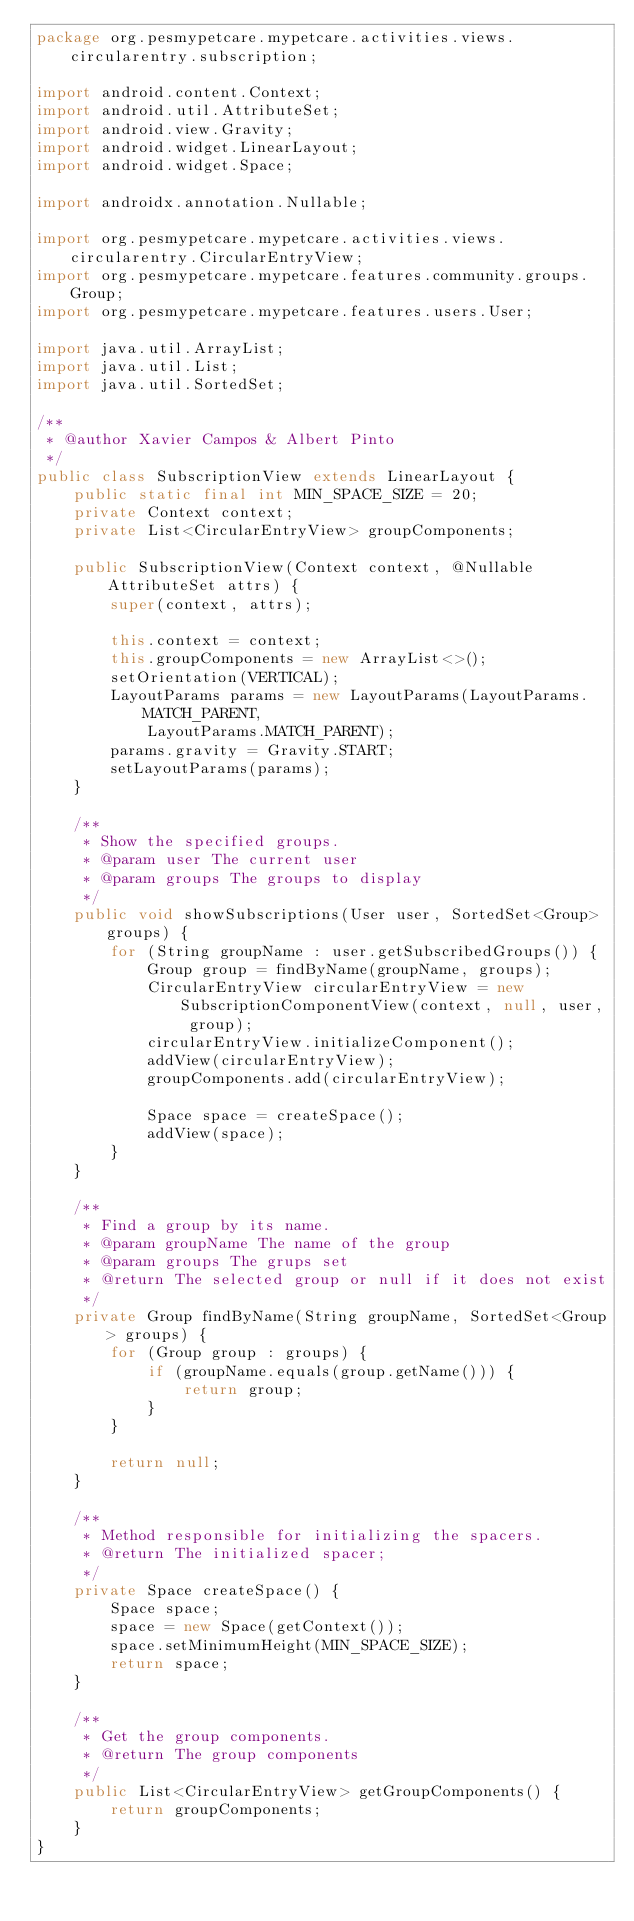Convert code to text. <code><loc_0><loc_0><loc_500><loc_500><_Java_>package org.pesmypetcare.mypetcare.activities.views.circularentry.subscription;

import android.content.Context;
import android.util.AttributeSet;
import android.view.Gravity;
import android.widget.LinearLayout;
import android.widget.Space;

import androidx.annotation.Nullable;

import org.pesmypetcare.mypetcare.activities.views.circularentry.CircularEntryView;
import org.pesmypetcare.mypetcare.features.community.groups.Group;
import org.pesmypetcare.mypetcare.features.users.User;

import java.util.ArrayList;
import java.util.List;
import java.util.SortedSet;

/**
 * @author Xavier Campos & Albert Pinto
 */
public class SubscriptionView extends LinearLayout {
    public static final int MIN_SPACE_SIZE = 20;
    private Context context;
    private List<CircularEntryView> groupComponents;

    public SubscriptionView(Context context, @Nullable AttributeSet attrs) {
        super(context, attrs);

        this.context = context;
        this.groupComponents = new ArrayList<>();
        setOrientation(VERTICAL);
        LayoutParams params = new LayoutParams(LayoutParams.MATCH_PARENT,
            LayoutParams.MATCH_PARENT);
        params.gravity = Gravity.START;
        setLayoutParams(params);
    }

    /**
     * Show the specified groups.
     * @param user The current user
     * @param groups The groups to display
     */
    public void showSubscriptions(User user, SortedSet<Group> groups) {
        for (String groupName : user.getSubscribedGroups()) {
            Group group = findByName(groupName, groups);
            CircularEntryView circularEntryView = new SubscriptionComponentView(context, null, user, group);
            circularEntryView.initializeComponent();
            addView(circularEntryView);
            groupComponents.add(circularEntryView);

            Space space = createSpace();
            addView(space);
        }
    }

    /**
     * Find a group by its name.
     * @param groupName The name of the group
     * @param groups The grups set
     * @return The selected group or null if it does not exist
     */
    private Group findByName(String groupName, SortedSet<Group> groups) {
        for (Group group : groups) {
            if (groupName.equals(group.getName())) {
                return group;
            }
        }

        return null;
    }

    /**
     * Method responsible for initializing the spacers.
     * @return The initialized spacer;
     */
    private Space createSpace() {
        Space space;
        space = new Space(getContext());
        space.setMinimumHeight(MIN_SPACE_SIZE);
        return space;
    }

    /**
     * Get the group components.
     * @return The group components
     */
    public List<CircularEntryView> getGroupComponents() {
        return groupComponents;
    }
}
</code> 